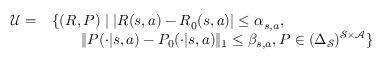<formula> <loc_0><loc_0><loc_500><loc_500>\begin{array} { r l } { \mathcal { U } = } & { \{ ( R , P ) | | R ( s , a ) - R _ { 0 } ( s , a ) | \leq \alpha _ { s , a } , } \\ & { \quad \| P ( \cdot | s , a ) - P _ { 0 } ( \cdot | s , a ) \| _ { 1 } \leq \beta _ { s , a } , P \in ( \Delta _ { \mathcal { S } } ) ^ { \mathcal { S } \times \mathcal { A } } \} } \end{array}</formula> 